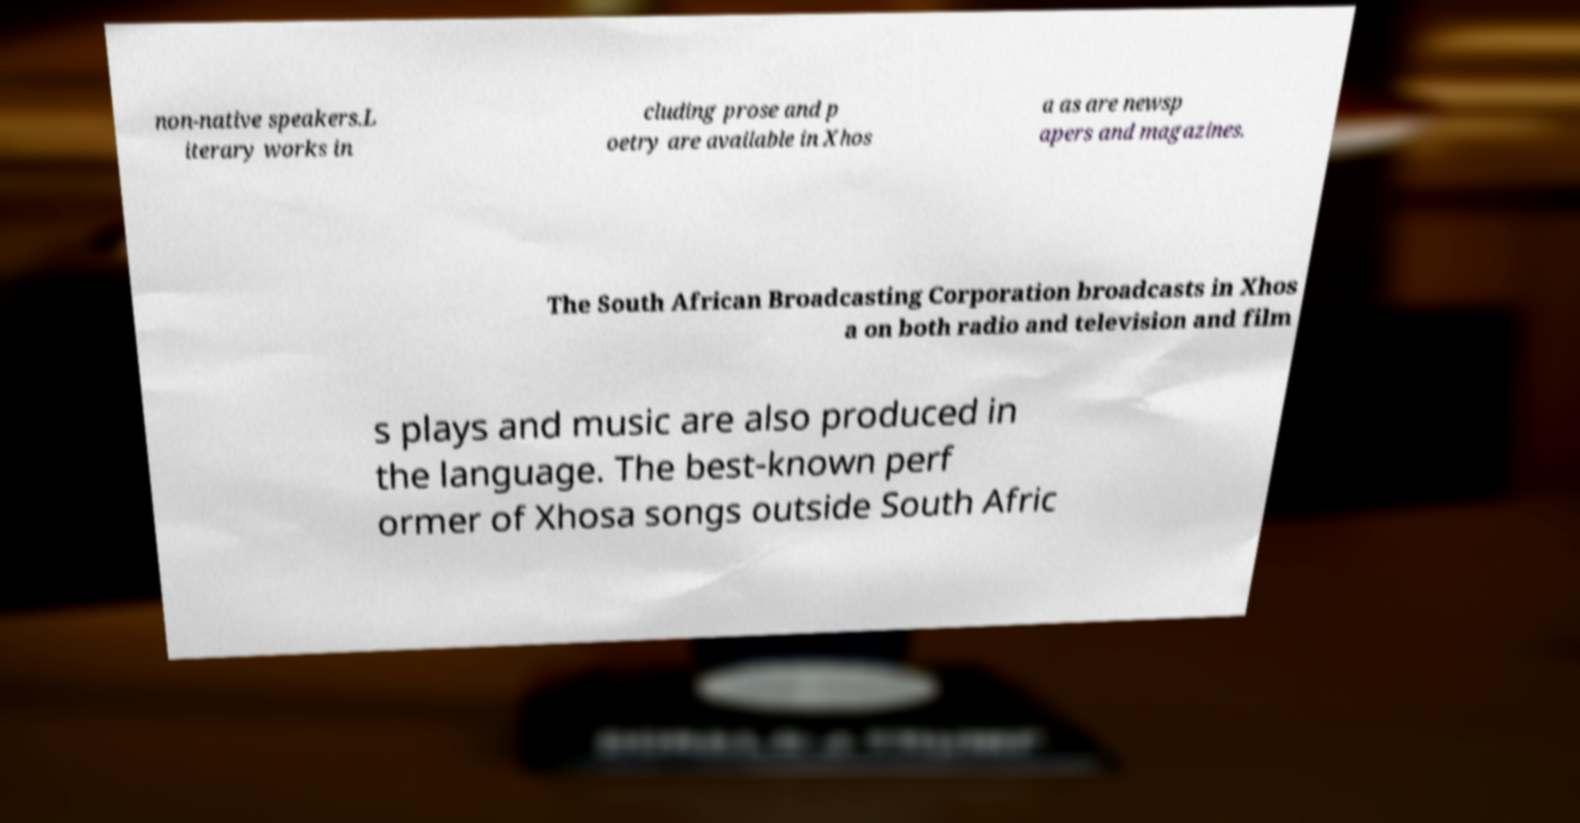Can you accurately transcribe the text from the provided image for me? non-native speakers.L iterary works in cluding prose and p oetry are available in Xhos a as are newsp apers and magazines. The South African Broadcasting Corporation broadcasts in Xhos a on both radio and television and film s plays and music are also produced in the language. The best-known perf ormer of Xhosa songs outside South Afric 